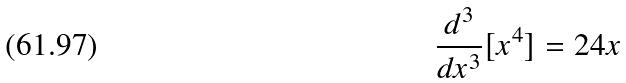<formula> <loc_0><loc_0><loc_500><loc_500>\frac { d ^ { 3 } } { d x ^ { 3 } } [ x ^ { 4 } ] = 2 4 x</formula> 